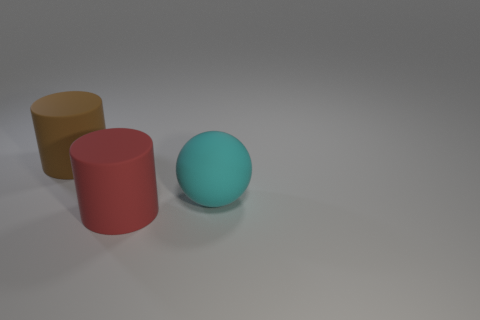There is a thing that is right of the red object; what shape is it?
Provide a succinct answer. Sphere. Is the color of the cylinder behind the big cyan object the same as the object that is to the right of the red thing?
Ensure brevity in your answer.  No. What number of large cylinders are both right of the big brown rubber cylinder and left of the big red cylinder?
Your answer should be very brief. 0. There is a ball that is the same material as the red cylinder; what size is it?
Offer a terse response. Large. The red cylinder has what size?
Offer a very short reply. Large. What material is the brown cylinder?
Make the answer very short. Rubber. There is a object behind the cyan object; is it the same size as the red matte object?
Your response must be concise. Yes. What number of things are either small cyan balls or balls?
Make the answer very short. 1. There is a matte thing that is both in front of the brown matte cylinder and to the left of the big cyan rubber thing; what is its size?
Offer a terse response. Large. How many big cyan matte things are there?
Your answer should be very brief. 1. 